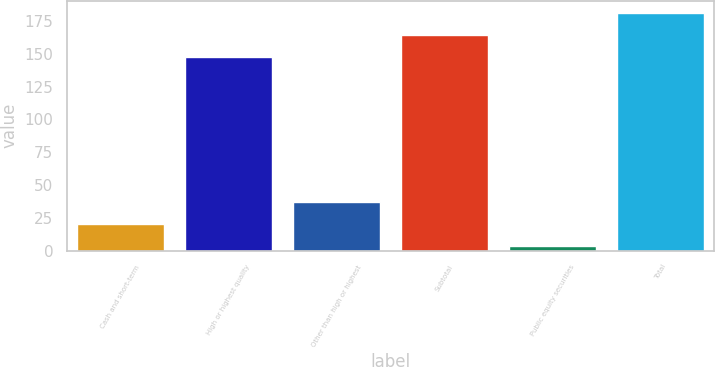<chart> <loc_0><loc_0><loc_500><loc_500><bar_chart><fcel>Cash and short-term<fcel>High or highest quality<fcel>Other than high or highest<fcel>Subtotal<fcel>Public equity securities<fcel>Total<nl><fcel>20.21<fcel>147.5<fcel>37.22<fcel>164.51<fcel>3.2<fcel>181.52<nl></chart> 